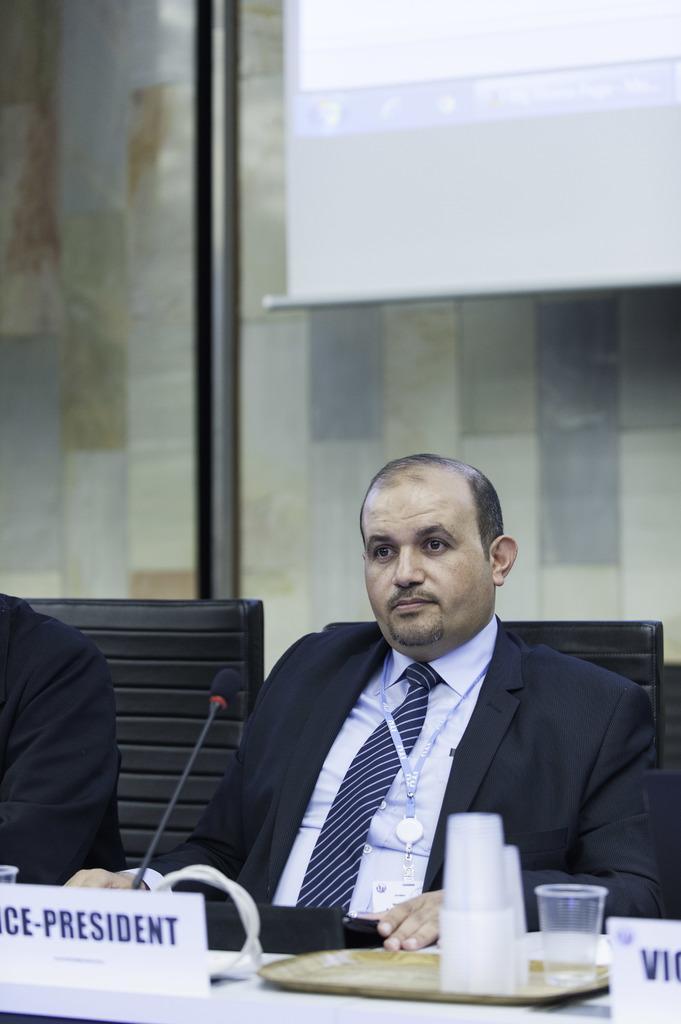Please provide a concise description of this image. In this image, in the foreground I can see a person who is vice president sitting on the chair, and at the top I can see the screen, there are some glasses on the plate. 